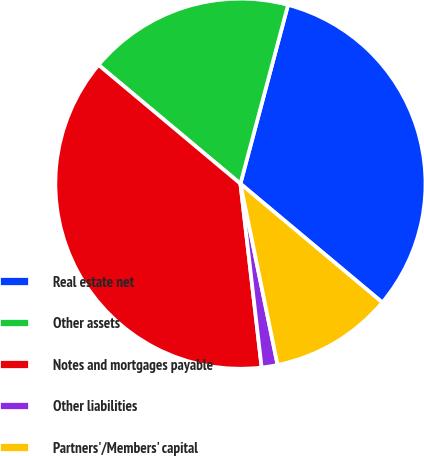<chart> <loc_0><loc_0><loc_500><loc_500><pie_chart><fcel>Real estate net<fcel>Other assets<fcel>Notes and mortgages payable<fcel>Other liabilities<fcel>Partners'/Members' capital<nl><fcel>31.95%<fcel>18.05%<fcel>37.92%<fcel>1.39%<fcel>10.69%<nl></chart> 